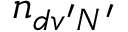<formula> <loc_0><loc_0><loc_500><loc_500>n _ { d v ^ { \prime } N ^ { \prime } }</formula> 